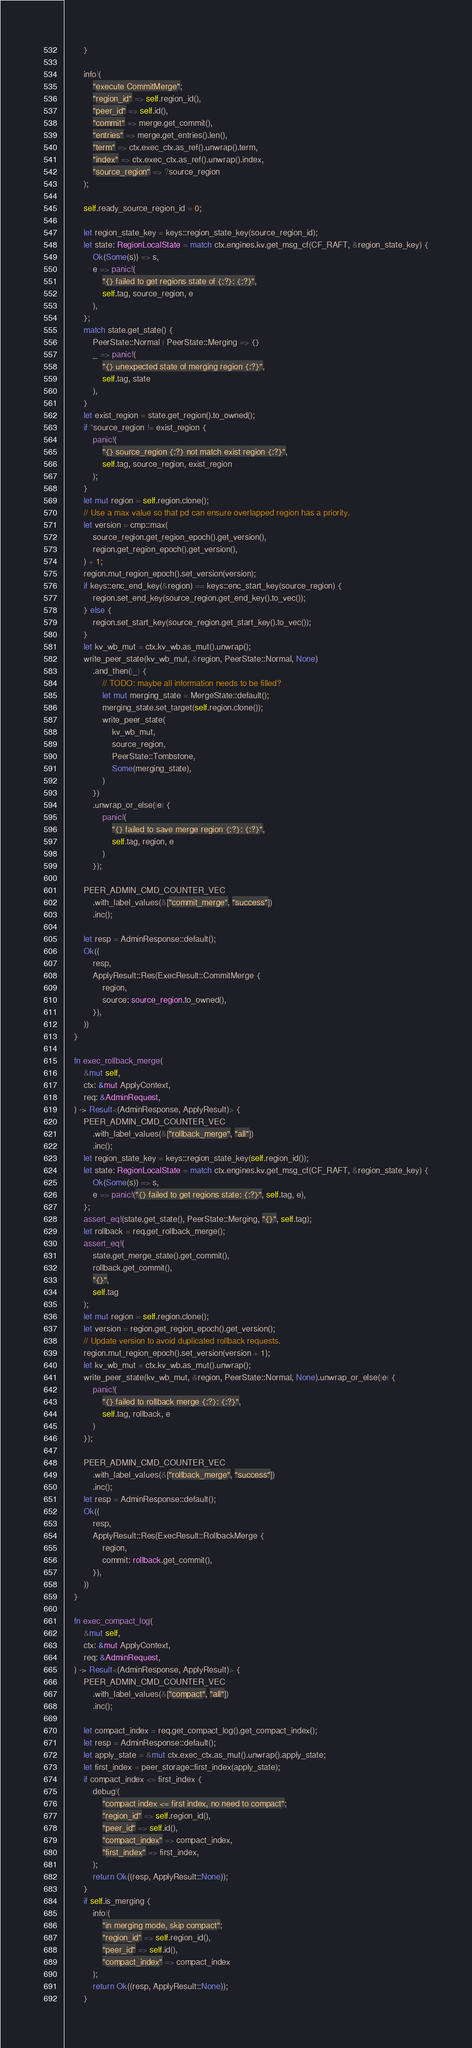Convert code to text. <code><loc_0><loc_0><loc_500><loc_500><_Rust_>        }

        info!(
            "execute CommitMerge";
            "region_id" => self.region_id(),
            "peer_id" => self.id(),
            "commit" => merge.get_commit(),
            "entries" => merge.get_entries().len(),
            "term" => ctx.exec_ctx.as_ref().unwrap().term,
            "index" => ctx.exec_ctx.as_ref().unwrap().index,
            "source_region" => ?source_region
        );

        self.ready_source_region_id = 0;

        let region_state_key = keys::region_state_key(source_region_id);
        let state: RegionLocalState = match ctx.engines.kv.get_msg_cf(CF_RAFT, &region_state_key) {
            Ok(Some(s)) => s,
            e => panic!(
                "{} failed to get regions state of {:?}: {:?}",
                self.tag, source_region, e
            ),
        };
        match state.get_state() {
            PeerState::Normal | PeerState::Merging => {}
            _ => panic!(
                "{} unexpected state of merging region {:?}",
                self.tag, state
            ),
        }
        let exist_region = state.get_region().to_owned();
        if *source_region != exist_region {
            panic!(
                "{} source_region {:?} not match exist region {:?}",
                self.tag, source_region, exist_region
            );
        }
        let mut region = self.region.clone();
        // Use a max value so that pd can ensure overlapped region has a priority.
        let version = cmp::max(
            source_region.get_region_epoch().get_version(),
            region.get_region_epoch().get_version(),
        ) + 1;
        region.mut_region_epoch().set_version(version);
        if keys::enc_end_key(&region) == keys::enc_start_key(source_region) {
            region.set_end_key(source_region.get_end_key().to_vec());
        } else {
            region.set_start_key(source_region.get_start_key().to_vec());
        }
        let kv_wb_mut = ctx.kv_wb.as_mut().unwrap();
        write_peer_state(kv_wb_mut, &region, PeerState::Normal, None)
            .and_then(|_| {
                // TODO: maybe all information needs to be filled?
                let mut merging_state = MergeState::default();
                merging_state.set_target(self.region.clone());
                write_peer_state(
                    kv_wb_mut,
                    source_region,
                    PeerState::Tombstone,
                    Some(merging_state),
                )
            })
            .unwrap_or_else(|e| {
                panic!(
                    "{} failed to save merge region {:?}: {:?}",
                    self.tag, region, e
                )
            });

        PEER_ADMIN_CMD_COUNTER_VEC
            .with_label_values(&["commit_merge", "success"])
            .inc();

        let resp = AdminResponse::default();
        Ok((
            resp,
            ApplyResult::Res(ExecResult::CommitMerge {
                region,
                source: source_region.to_owned(),
            }),
        ))
    }

    fn exec_rollback_merge(
        &mut self,
        ctx: &mut ApplyContext,
        req: &AdminRequest,
    ) -> Result<(AdminResponse, ApplyResult)> {
        PEER_ADMIN_CMD_COUNTER_VEC
            .with_label_values(&["rollback_merge", "all"])
            .inc();
        let region_state_key = keys::region_state_key(self.region_id());
        let state: RegionLocalState = match ctx.engines.kv.get_msg_cf(CF_RAFT, &region_state_key) {
            Ok(Some(s)) => s,
            e => panic!("{} failed to get regions state: {:?}", self.tag, e),
        };
        assert_eq!(state.get_state(), PeerState::Merging, "{}", self.tag);
        let rollback = req.get_rollback_merge();
        assert_eq!(
            state.get_merge_state().get_commit(),
            rollback.get_commit(),
            "{}",
            self.tag
        );
        let mut region = self.region.clone();
        let version = region.get_region_epoch().get_version();
        // Update version to avoid duplicated rollback requests.
        region.mut_region_epoch().set_version(version + 1);
        let kv_wb_mut = ctx.kv_wb.as_mut().unwrap();
        write_peer_state(kv_wb_mut, &region, PeerState::Normal, None).unwrap_or_else(|e| {
            panic!(
                "{} failed to rollback merge {:?}: {:?}",
                self.tag, rollback, e
            )
        });

        PEER_ADMIN_CMD_COUNTER_VEC
            .with_label_values(&["rollback_merge", "success"])
            .inc();
        let resp = AdminResponse::default();
        Ok((
            resp,
            ApplyResult::Res(ExecResult::RollbackMerge {
                region,
                commit: rollback.get_commit(),
            }),
        ))
    }

    fn exec_compact_log(
        &mut self,
        ctx: &mut ApplyContext,
        req: &AdminRequest,
    ) -> Result<(AdminResponse, ApplyResult)> {
        PEER_ADMIN_CMD_COUNTER_VEC
            .with_label_values(&["compact", "all"])
            .inc();

        let compact_index = req.get_compact_log().get_compact_index();
        let resp = AdminResponse::default();
        let apply_state = &mut ctx.exec_ctx.as_mut().unwrap().apply_state;
        let first_index = peer_storage::first_index(apply_state);
        if compact_index <= first_index {
            debug!(
                "compact index <= first index, no need to compact";
                "region_id" => self.region_id(),
                "peer_id" => self.id(),
                "compact_index" => compact_index,
                "first_index" => first_index,
            );
            return Ok((resp, ApplyResult::None));
        }
        if self.is_merging {
            info!(
                "in merging mode, skip compact";
                "region_id" => self.region_id(),
                "peer_id" => self.id(),
                "compact_index" => compact_index
            );
            return Ok((resp, ApplyResult::None));
        }
</code> 